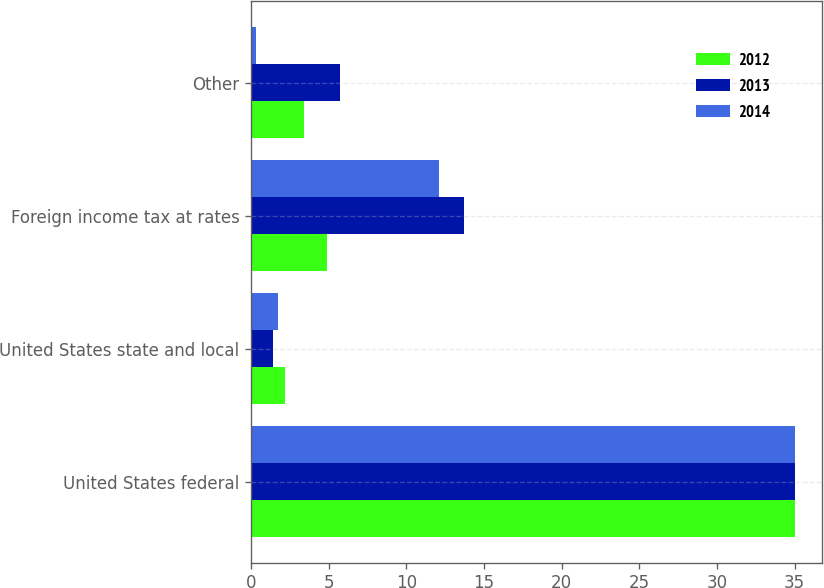<chart> <loc_0><loc_0><loc_500><loc_500><stacked_bar_chart><ecel><fcel>United States federal<fcel>United States state and local<fcel>Foreign income tax at rates<fcel>Other<nl><fcel>2012<fcel>35<fcel>2.2<fcel>4.9<fcel>3.4<nl><fcel>2013<fcel>35<fcel>1.4<fcel>13.7<fcel>5.7<nl><fcel>2014<fcel>35<fcel>1.7<fcel>12.1<fcel>0.3<nl></chart> 